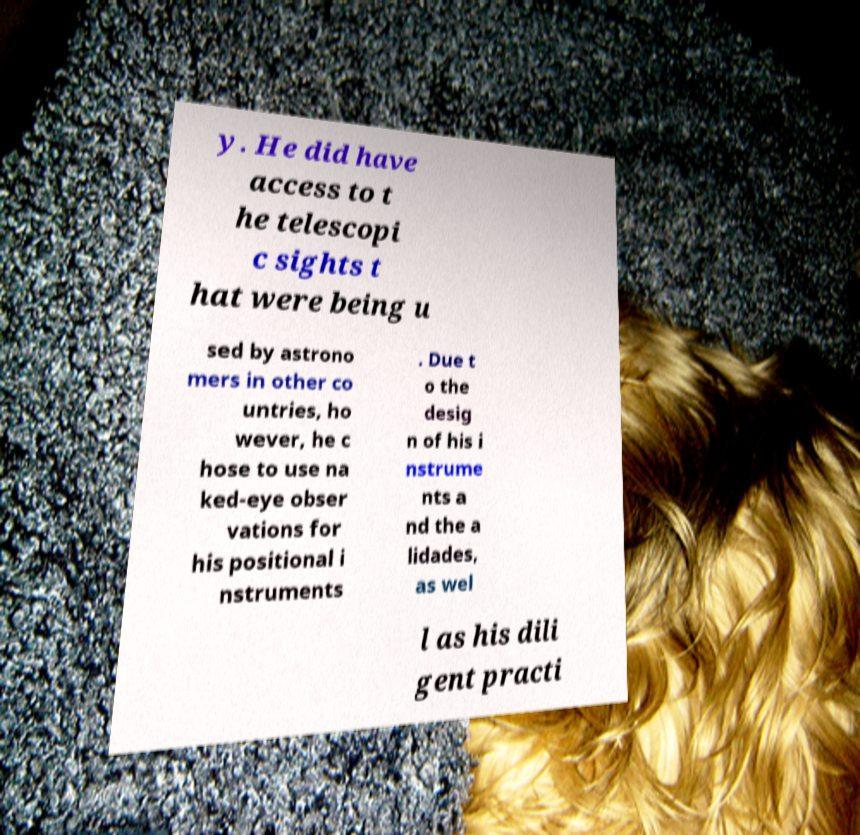Can you read and provide the text displayed in the image?This photo seems to have some interesting text. Can you extract and type it out for me? y. He did have access to t he telescopi c sights t hat were being u sed by astrono mers in other co untries, ho wever, he c hose to use na ked-eye obser vations for his positional i nstruments . Due t o the desig n of his i nstrume nts a nd the a lidades, as wel l as his dili gent practi 